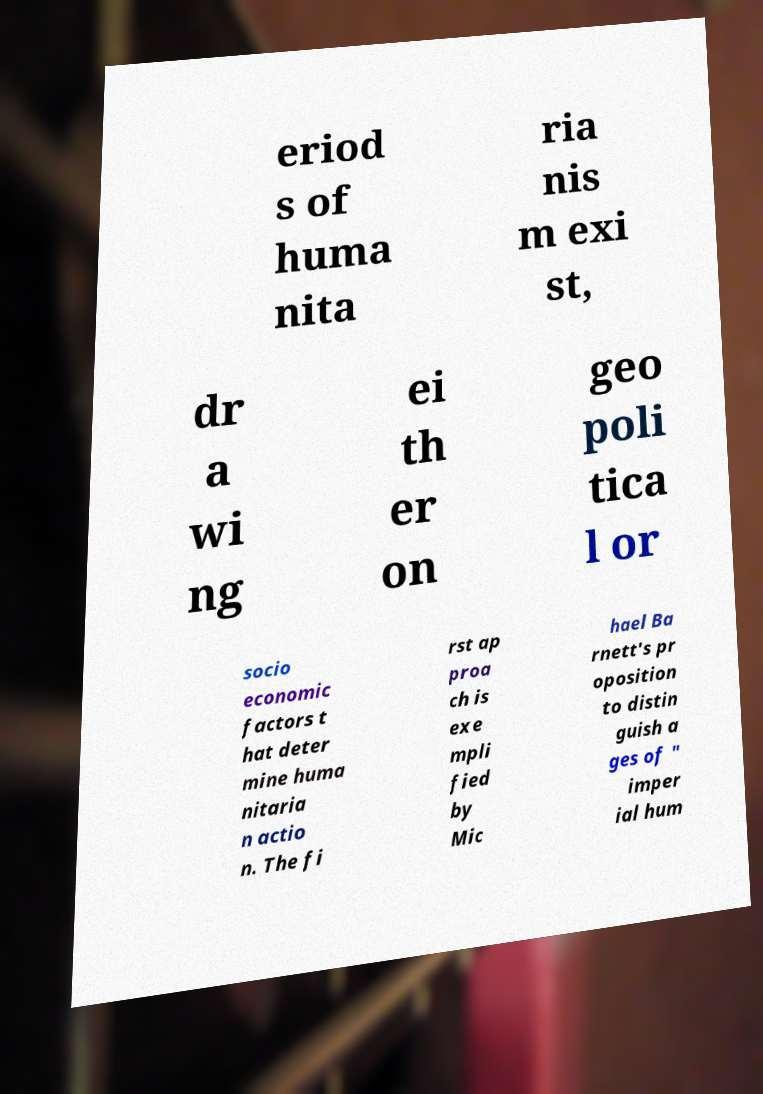Can you accurately transcribe the text from the provided image for me? eriod s of huma nita ria nis m exi st, dr a wi ng ei th er on geo poli tica l or socio economic factors t hat deter mine huma nitaria n actio n. The fi rst ap proa ch is exe mpli fied by Mic hael Ba rnett's pr oposition to distin guish a ges of " imper ial hum 